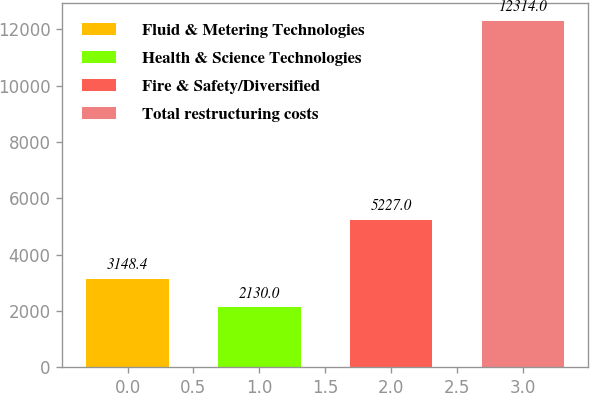Convert chart to OTSL. <chart><loc_0><loc_0><loc_500><loc_500><bar_chart><fcel>Fluid & Metering Technologies<fcel>Health & Science Technologies<fcel>Fire & Safety/Diversified<fcel>Total restructuring costs<nl><fcel>3148.4<fcel>2130<fcel>5227<fcel>12314<nl></chart> 